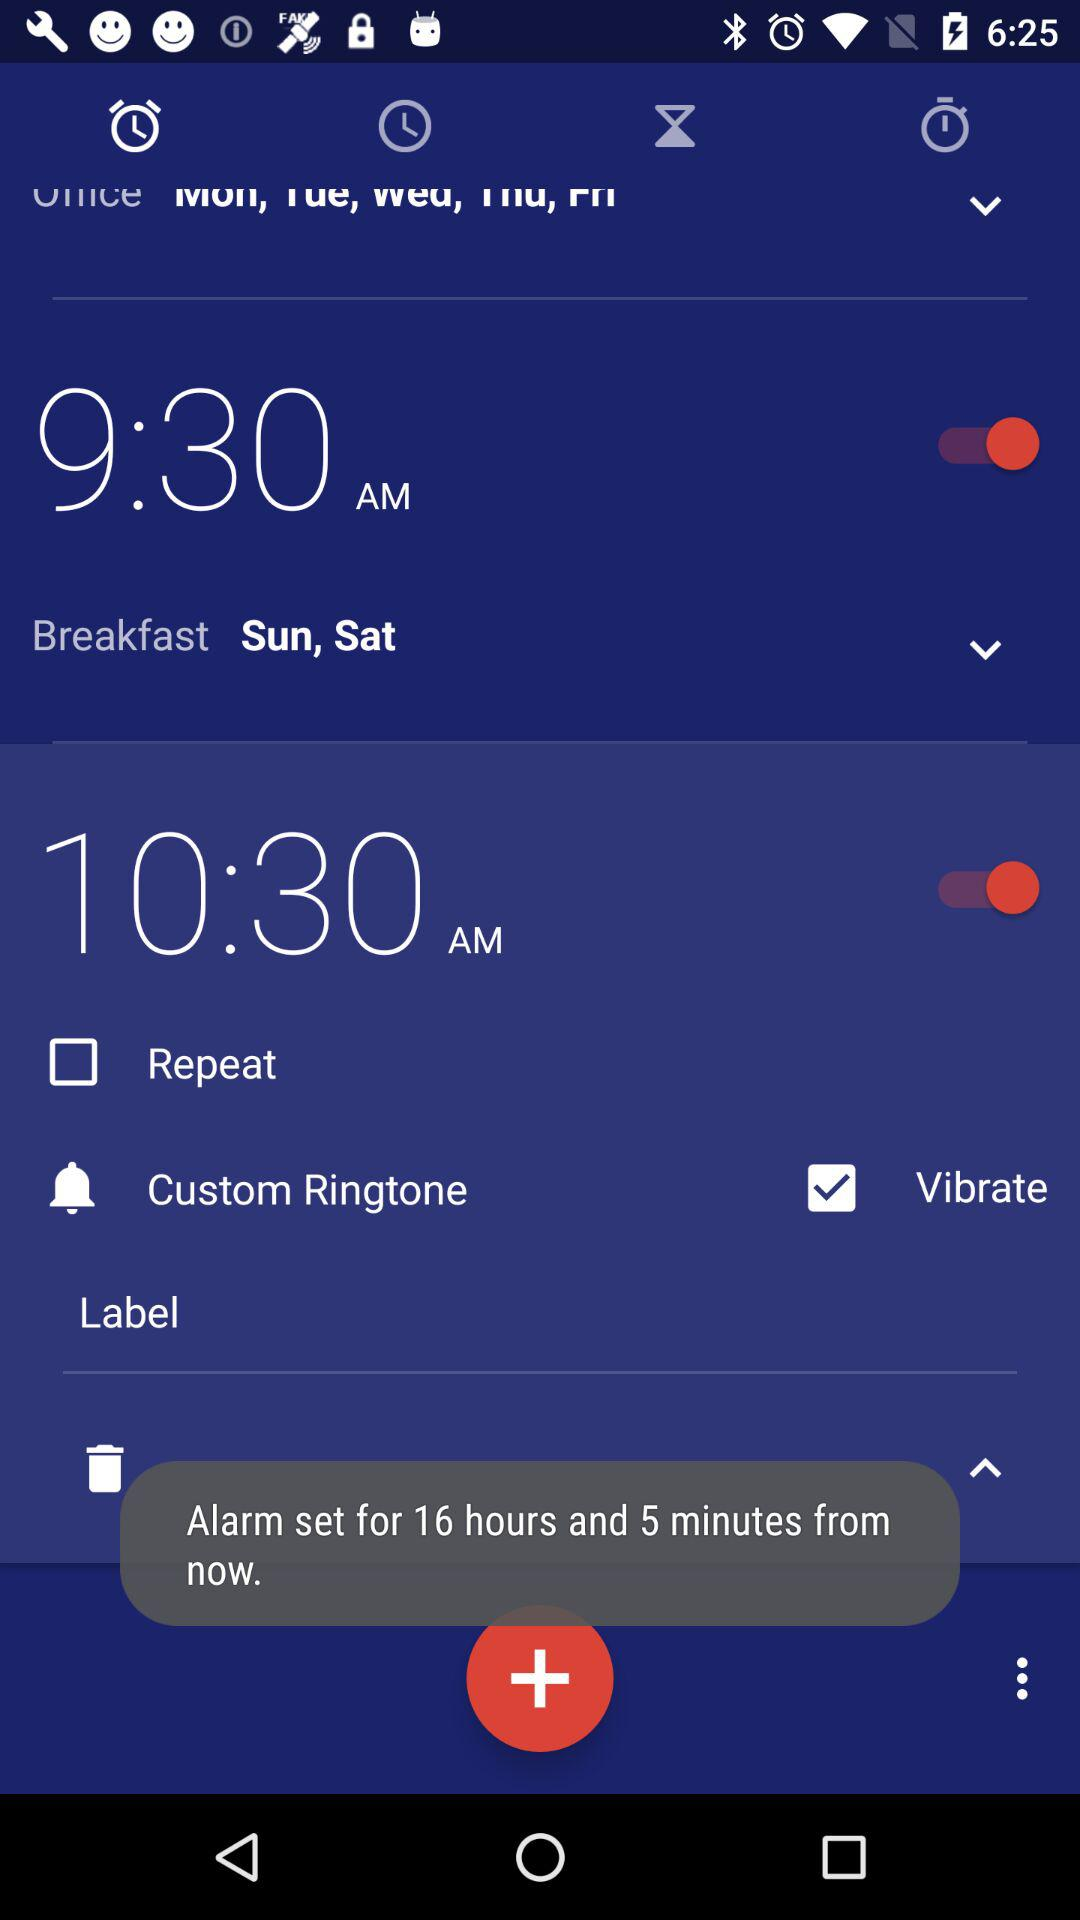Which days are selected for the breakfast alarm? The days selected for the breakfast alarm are Sunday and Saturday. 